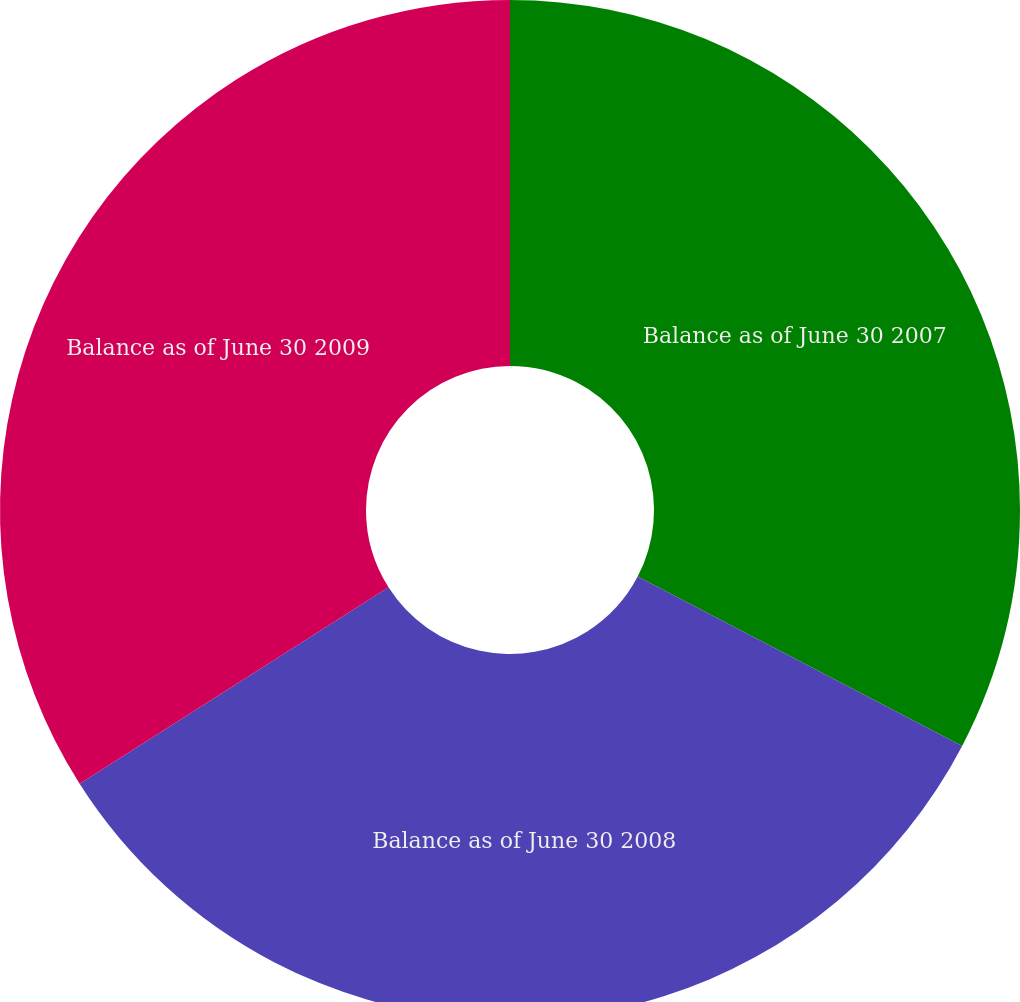<chart> <loc_0><loc_0><loc_500><loc_500><pie_chart><fcel>Balance as of June 30 2007<fcel>Balance as of June 30 2008<fcel>Balance as of June 30 2009<nl><fcel>32.65%<fcel>33.33%<fcel>34.01%<nl></chart> 